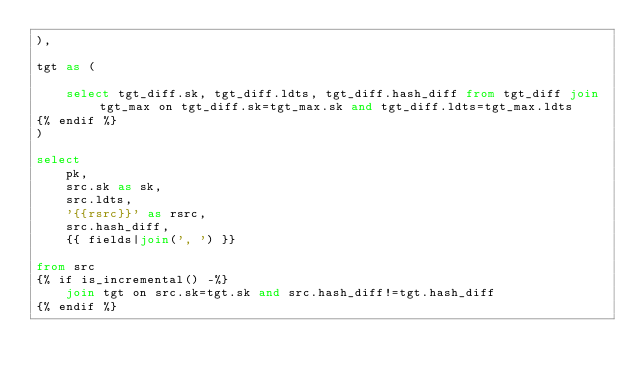Convert code to text. <code><loc_0><loc_0><loc_500><loc_500><_SQL_>),

tgt as (

    select tgt_diff.sk, tgt_diff.ldts, tgt_diff.hash_diff from tgt_diff join tgt_max on tgt_diff.sk=tgt_max.sk and tgt_diff.ldts=tgt_max.ldts
{% endif %}
)

select 
    pk,
    src.sk as sk,
	src.ldts,
    '{{rsrc}}' as rsrc,
    src.hash_diff,
	{{ fields|join(', ') }}

from src
{% if is_incremental() -%}
    join tgt on src.sk=tgt.sk and src.hash_diff!=tgt.hash_diff 
{% endif %}


</code> 